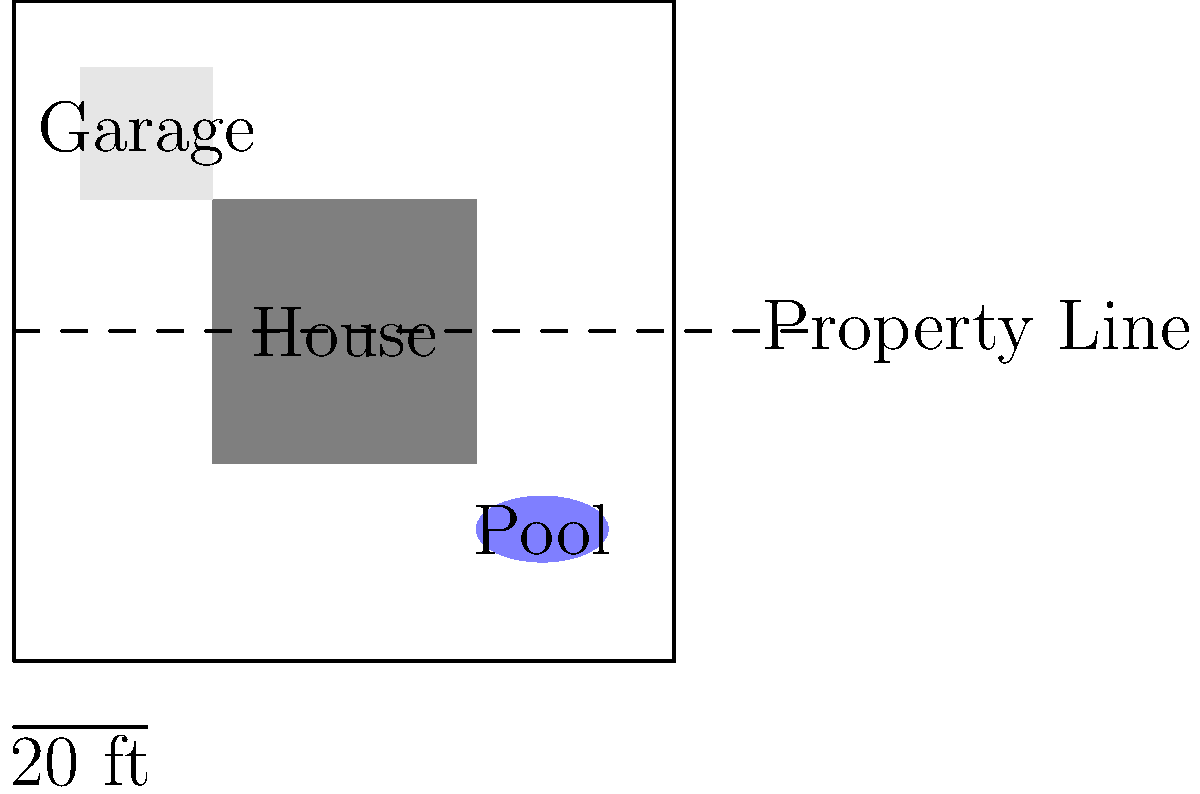Based on the aerial image of a residential property, which structure is most likely to be in violation of typical setback requirements for a suburban zoning district? To determine potential zoning violations related to setback requirements, we need to analyze each structure's position relative to the property lines:

1. House: The main dwelling appears to be well within the property boundaries, likely meeting typical setback requirements for front, rear, and side yards.

2. Garage: This structure is positioned close to the left property line and the front property line. In many suburban zoning districts, accessory structures like garages are required to maintain a certain distance from property lines, typically 5-10 feet.

3. Pool: The pool is located in the rear right corner of the property. While pools often have specific setback requirements, this one appears to be maintaining some distance from the property lines.

4. Property line extension: The dashed line extending beyond the property boundary suggests a possible easement or right-of-way, which could affect setback calculations.

Given the proximity of the garage to both the left and front property lines, it is the structure most likely to be in violation of typical setback requirements. Accessory structures often have stricter setback rules than primary dwellings, and the garage's position suggests it may encroach on these required distances.

It's important to note that setback requirements can vary significantly between jurisdictions and even within different zones of the same municipality. A thorough review of the specific zoning ordinances applicable to this property would be necessary to make a definitive determination.
Answer: Garage 